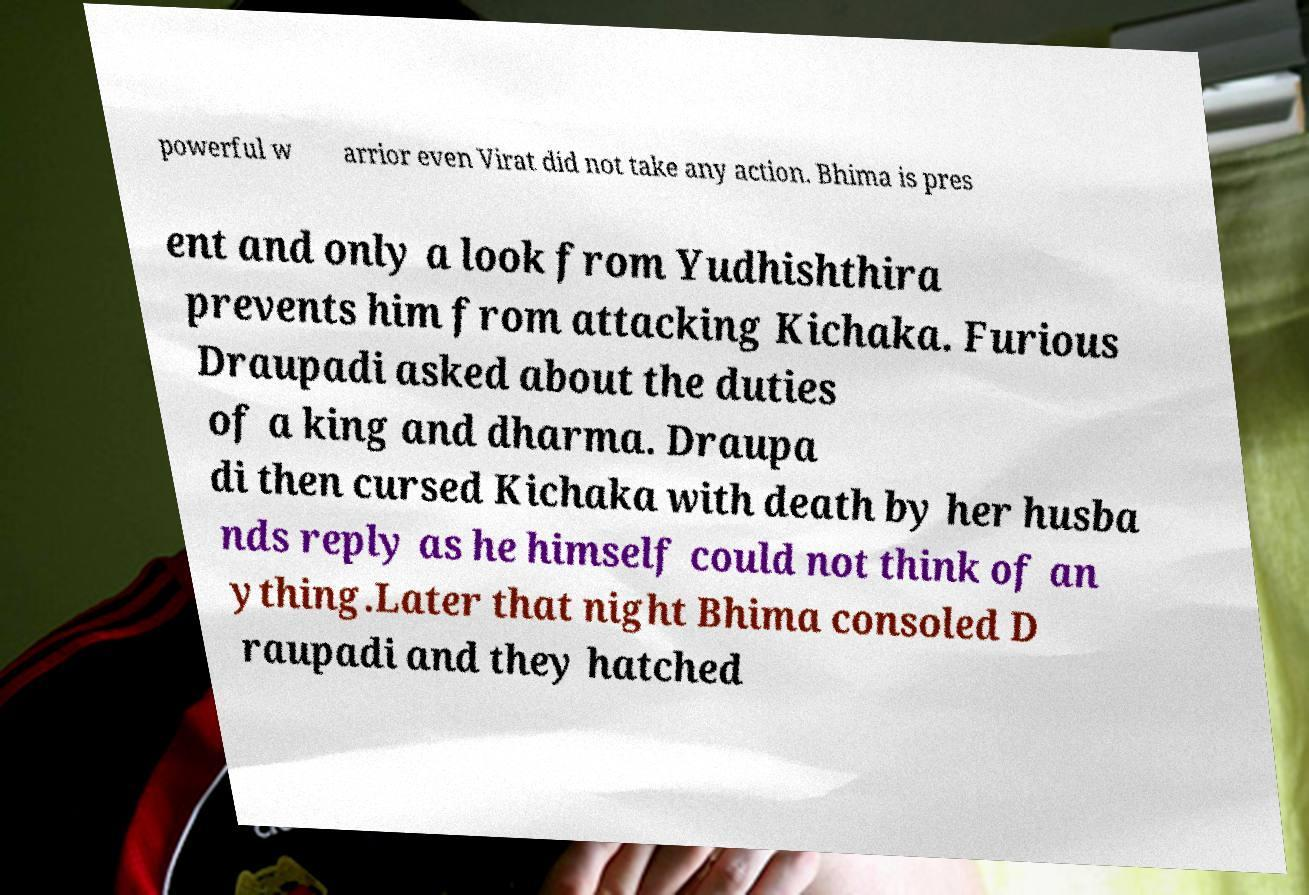Can you accurately transcribe the text from the provided image for me? powerful w arrior even Virat did not take any action. Bhima is pres ent and only a look from Yudhishthira prevents him from attacking Kichaka. Furious Draupadi asked about the duties of a king and dharma. Draupa di then cursed Kichaka with death by her husba nds reply as he himself could not think of an ything.Later that night Bhima consoled D raupadi and they hatched 